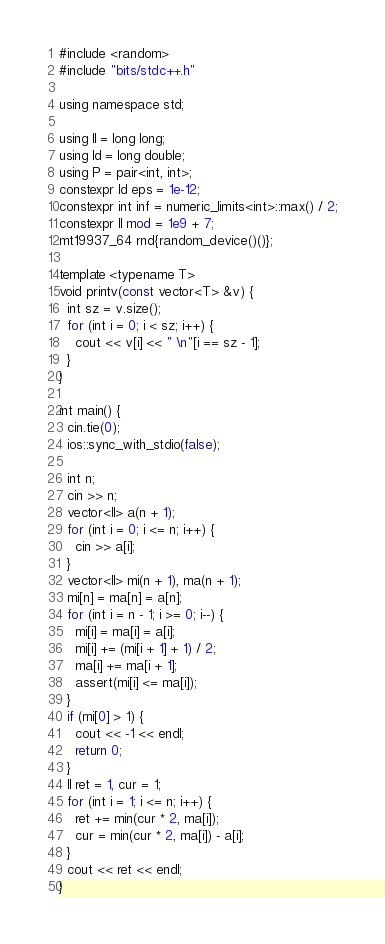<code> <loc_0><loc_0><loc_500><loc_500><_Rust_>#include <random>
#include "bits/stdc++.h"

using namespace std;

using ll = long long;
using ld = long double;
using P = pair<int, int>;
constexpr ld eps = 1e-12;
constexpr int inf = numeric_limits<int>::max() / 2;
constexpr ll mod = 1e9 + 7;
mt19937_64 rnd{random_device()()};

template <typename T>
void printv(const vector<T> &v) {
  int sz = v.size();
  for (int i = 0; i < sz; i++) {
    cout << v[i] << " \n"[i == sz - 1];
  }
}

int main() {
  cin.tie(0);
  ios::sync_with_stdio(false);

  int n;
  cin >> n;
  vector<ll> a(n + 1);
  for (int i = 0; i <= n; i++) {
    cin >> a[i];
  }
  vector<ll> mi(n + 1), ma(n + 1);
  mi[n] = ma[n] = a[n];
  for (int i = n - 1; i >= 0; i--) {
    mi[i] = ma[i] = a[i];
    mi[i] += (mi[i + 1] + 1) / 2;
    ma[i] += ma[i + 1];
    assert(mi[i] <= ma[i]);
  }
  if (mi[0] > 1) {
    cout << -1 << endl;
    return 0;
  }
  ll ret = 1, cur = 1;
  for (int i = 1; i <= n; i++) {
    ret += min(cur * 2, ma[i]);
    cur = min(cur * 2, ma[i]) - a[i];
  }
  cout << ret << endl;
}
</code> 